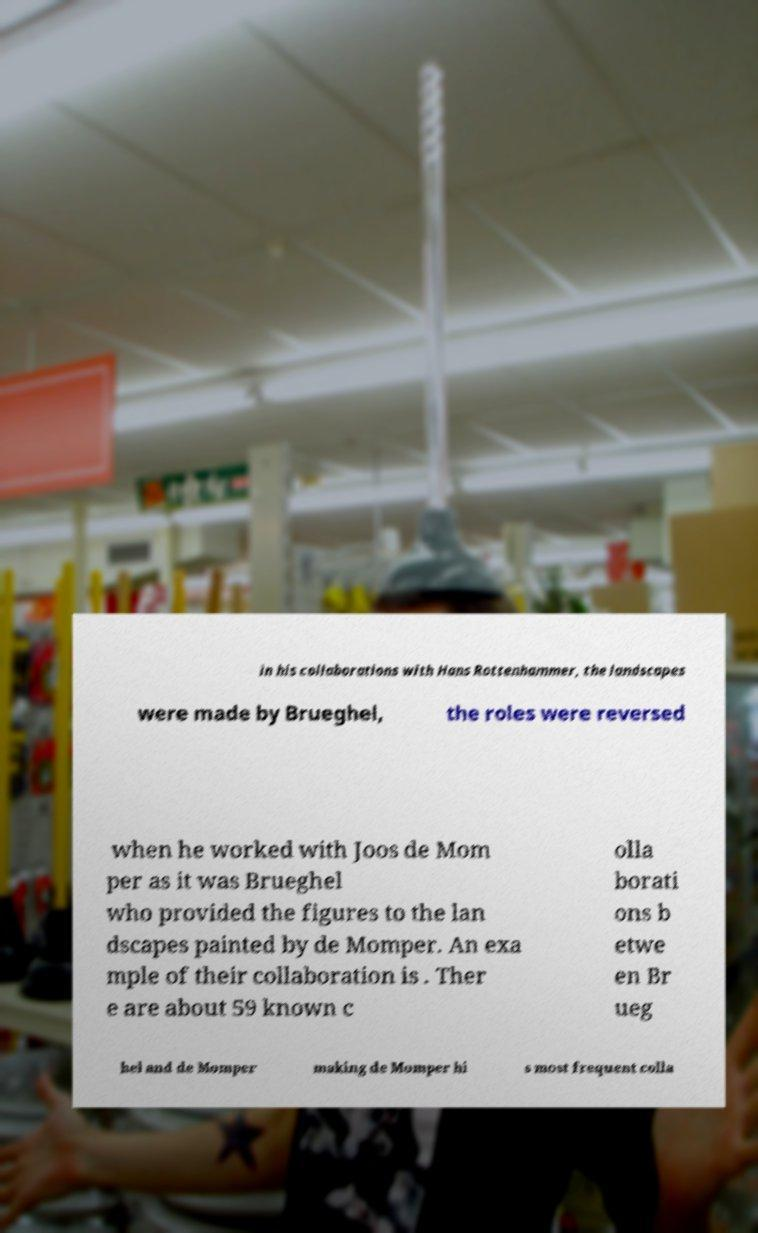Please identify and transcribe the text found in this image. in his collaborations with Hans Rottenhammer, the landscapes were made by Brueghel, the roles were reversed when he worked with Joos de Mom per as it was Brueghel who provided the figures to the lan dscapes painted by de Momper. An exa mple of their collaboration is . Ther e are about 59 known c olla borati ons b etwe en Br ueg hel and de Momper making de Momper hi s most frequent colla 